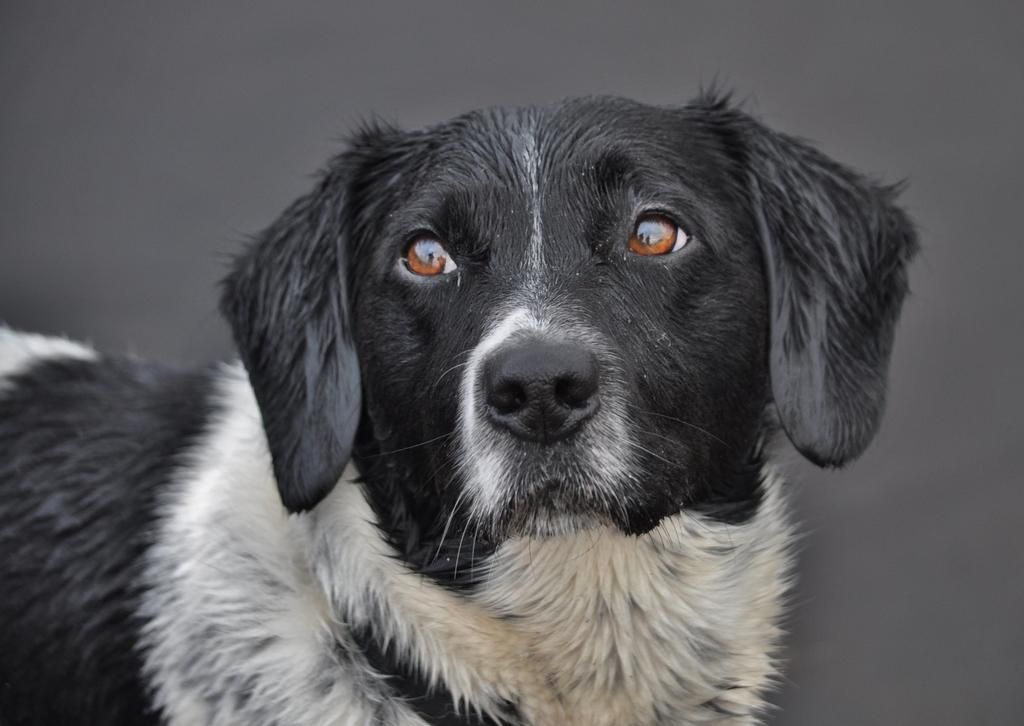What type of animal is in the image? There is a dog in the image. What color is the background of the image? The background of the image is gray in color. How much money is the dog holding in the image? There is no money present in the image; it features a dog with a gray background. 